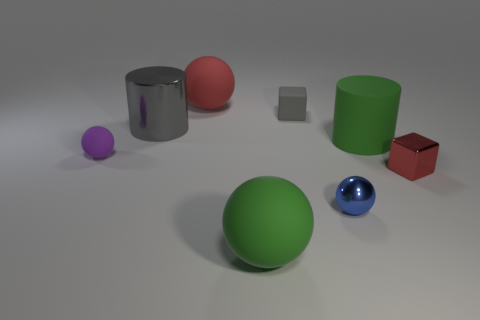Which objects in the scene are reflective? The cylinder and the small blue sphere are reflective, showing the environment and other objects in their surfaces. Are there any objects that stand out due to their shape? The cylinder stands out as it is the only object with a vertical orientation, different from the other spherical and box-shaped objects. 